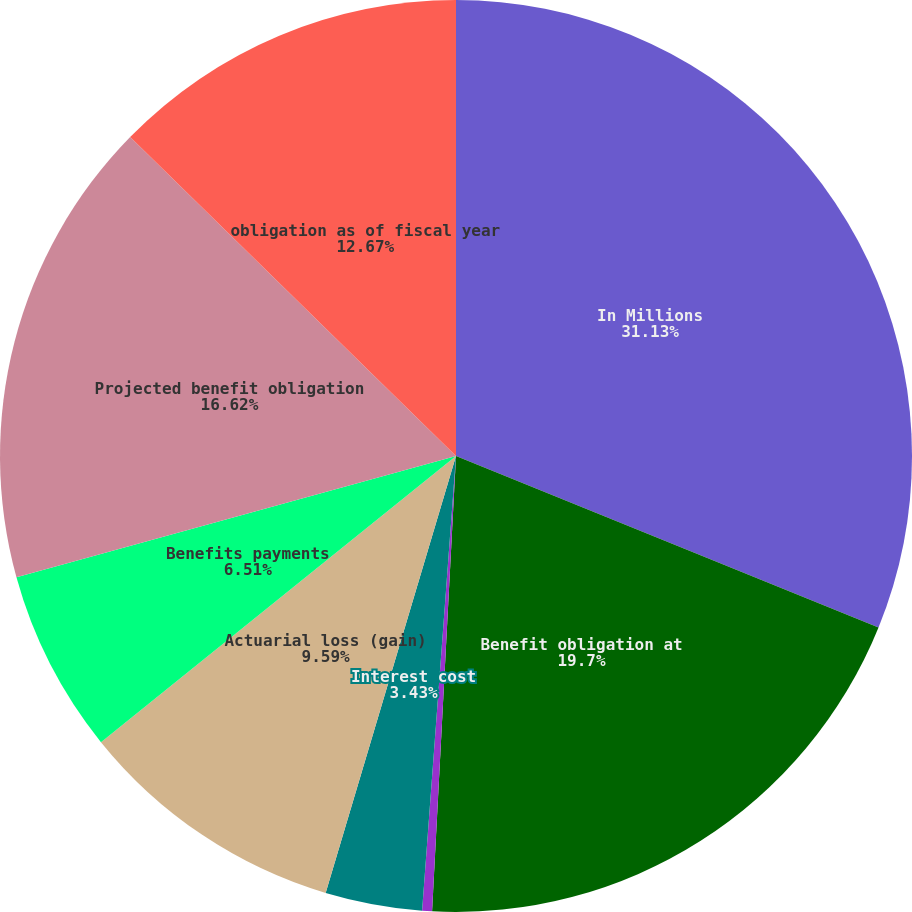Convert chart to OTSL. <chart><loc_0><loc_0><loc_500><loc_500><pie_chart><fcel>In Millions<fcel>Benefit obligation at<fcel>Service cost<fcel>Interest cost<fcel>Actuarial loss (gain)<fcel>Benefits payments<fcel>Projected benefit obligation<fcel>obligation as of fiscal year<nl><fcel>31.14%<fcel>19.7%<fcel>0.35%<fcel>3.43%<fcel>9.59%<fcel>6.51%<fcel>16.62%<fcel>12.67%<nl></chart> 